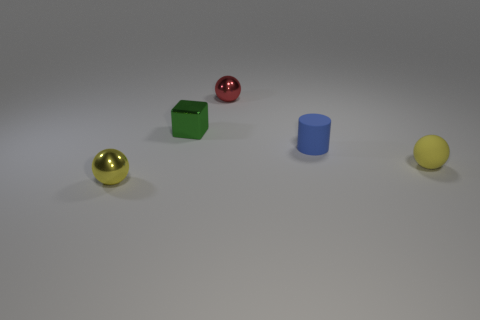Subtract all tiny shiny spheres. How many spheres are left? 1 Add 2 tiny rubber things. How many objects exist? 7 Subtract all yellow balls. How many balls are left? 1 Subtract 2 balls. How many balls are left? 1 Subtract all yellow cylinders. How many brown cubes are left? 0 Subtract all spheres. How many objects are left? 2 Subtract all green cylinders. Subtract all cyan blocks. How many cylinders are left? 1 Subtract all blue cylinders. Subtract all metal spheres. How many objects are left? 2 Add 1 tiny blue matte cylinders. How many tiny blue matte cylinders are left? 2 Add 3 tiny purple cubes. How many tiny purple cubes exist? 3 